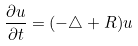<formula> <loc_0><loc_0><loc_500><loc_500>\frac { \partial u } { \partial t } = ( - \triangle + R ) u</formula> 